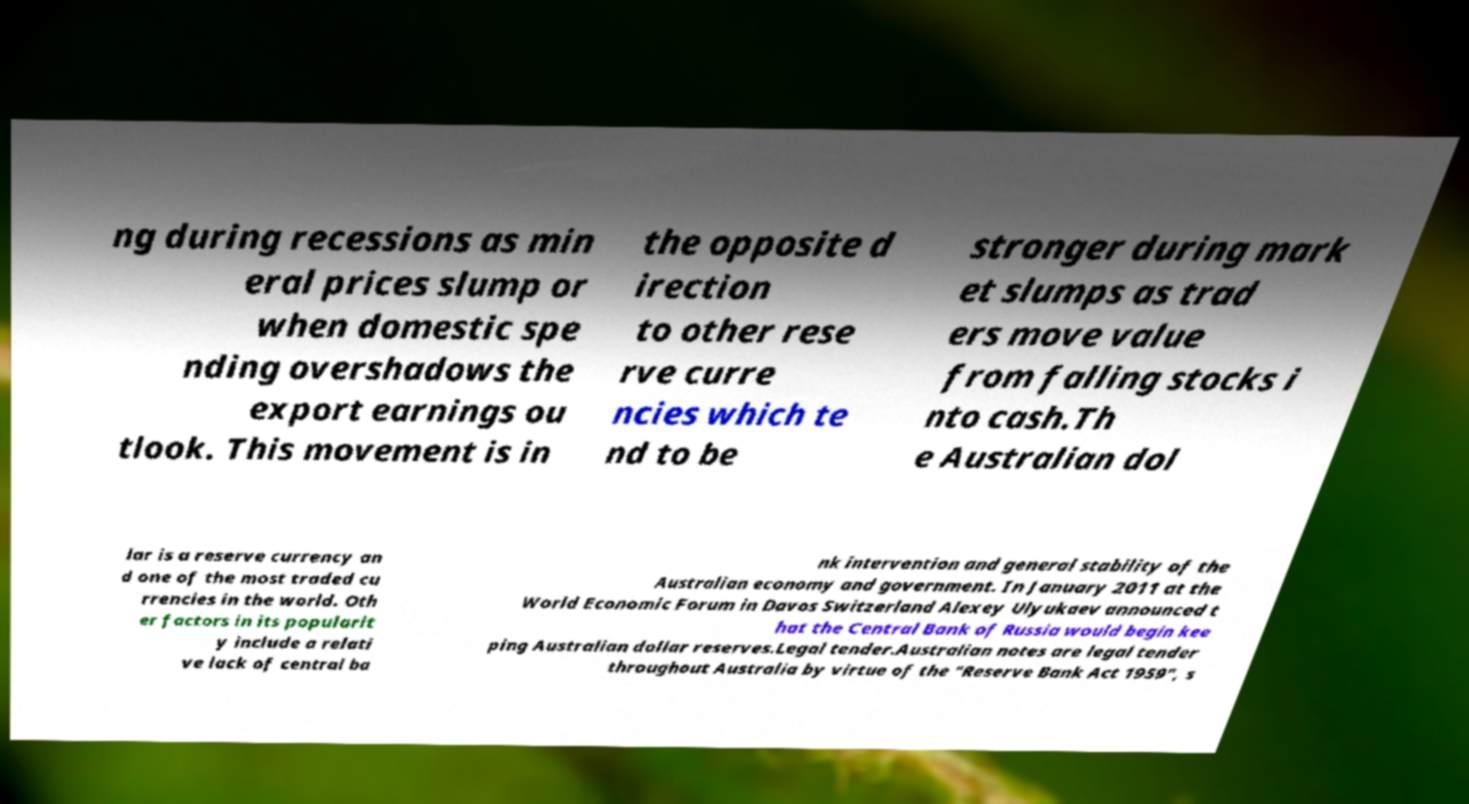Can you accurately transcribe the text from the provided image for me? ng during recessions as min eral prices slump or when domestic spe nding overshadows the export earnings ou tlook. This movement is in the opposite d irection to other rese rve curre ncies which te nd to be stronger during mark et slumps as trad ers move value from falling stocks i nto cash.Th e Australian dol lar is a reserve currency an d one of the most traded cu rrencies in the world. Oth er factors in its popularit y include a relati ve lack of central ba nk intervention and general stability of the Australian economy and government. In January 2011 at the World Economic Forum in Davos Switzerland Alexey Ulyukaev announced t hat the Central Bank of Russia would begin kee ping Australian dollar reserves.Legal tender.Australian notes are legal tender throughout Australia by virtue of the "Reserve Bank Act 1959", s 